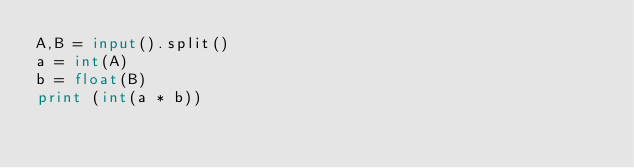Convert code to text. <code><loc_0><loc_0><loc_500><loc_500><_Python_>A,B = input().split()
a = int(A)
b = float(B)
print (int(a * b))</code> 